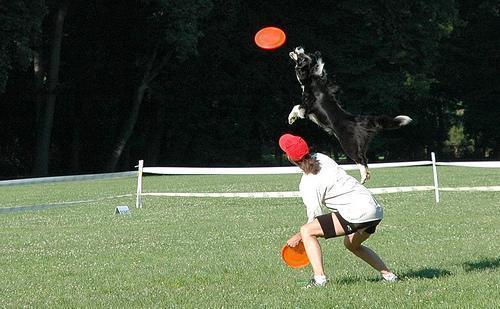What is the dog ready to do?
Pick the correct solution from the four options below to address the question.
Options: Roll over, ride, catch, walk. Catch. 